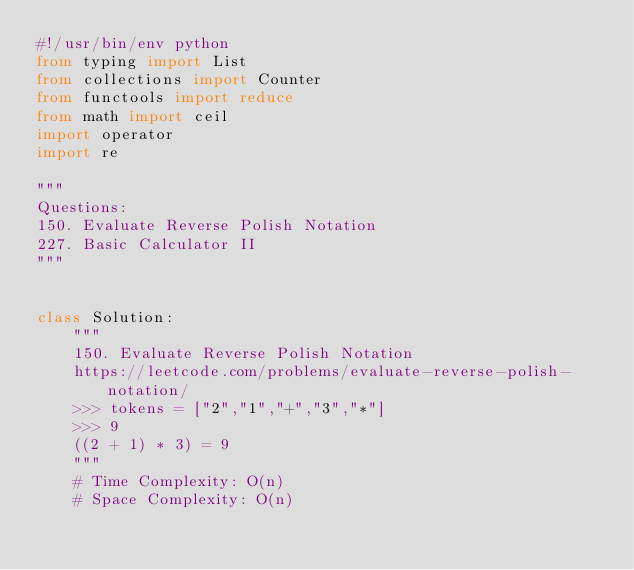<code> <loc_0><loc_0><loc_500><loc_500><_Python_>#!/usr/bin/env python
from typing import List
from collections import Counter
from functools import reduce
from math import ceil
import operator
import re

"""
Questions:
150. Evaluate Reverse Polish Notation
227. Basic Calculator II
"""


class Solution:
    """
    150. Evaluate Reverse Polish Notation
    https://leetcode.com/problems/evaluate-reverse-polish-notation/
    >>> tokens = ["2","1","+","3","*"]
    >>> 9
    ((2 + 1) * 3) = 9
    """
    # Time Complexity: O(n)
    # Space Complexity: O(n)</code> 